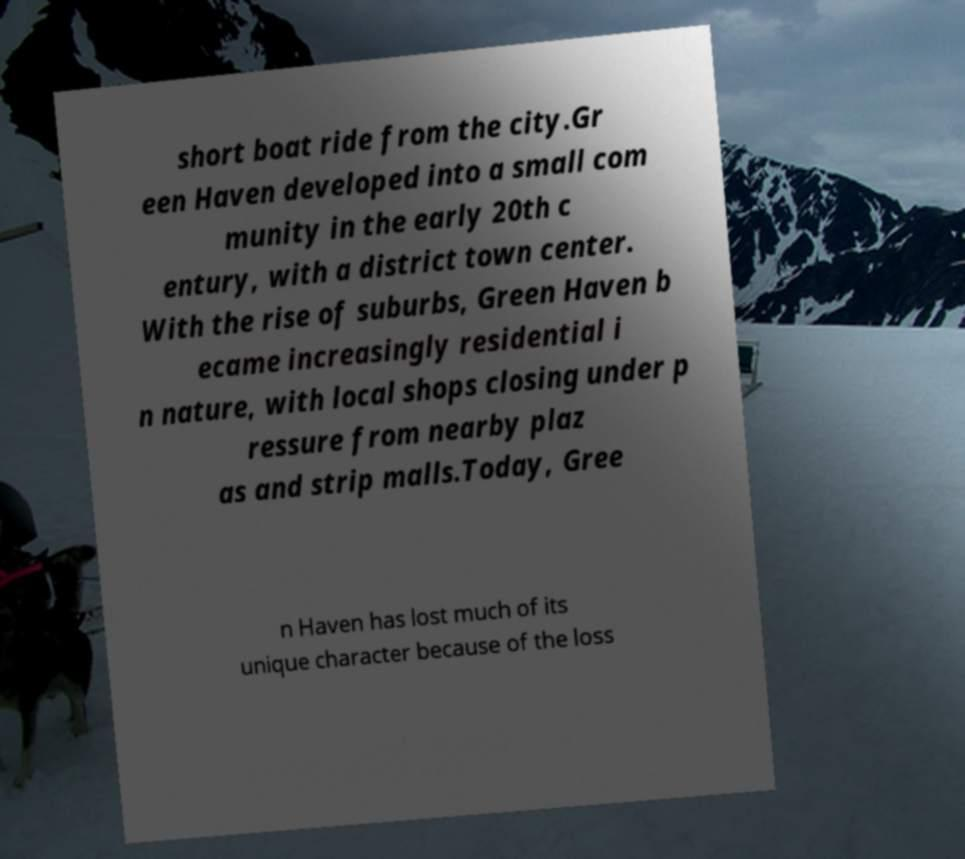There's text embedded in this image that I need extracted. Can you transcribe it verbatim? short boat ride from the city.Gr een Haven developed into a small com munity in the early 20th c entury, with a district town center. With the rise of suburbs, Green Haven b ecame increasingly residential i n nature, with local shops closing under p ressure from nearby plaz as and strip malls.Today, Gree n Haven has lost much of its unique character because of the loss 